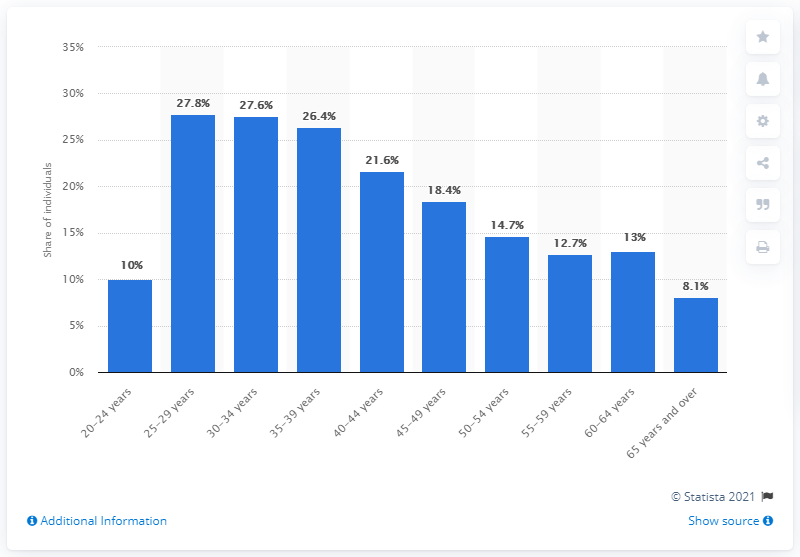Draw attention to some important aspects in this diagram. The age group with the lowest percentage of people who achieved a university degree was those who were 65 years and older. In 2019, approximately 27.8% of Italians aged 25 to 29 held a university degree. 